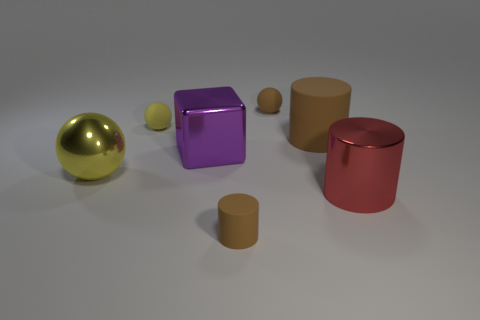Add 3 large purple blocks. How many objects exist? 10 Subtract all yellow metallic balls. How many balls are left? 2 Subtract all cubes. How many objects are left? 6 Add 6 small blue shiny cubes. How many small blue shiny cubes exist? 6 Subtract all brown cylinders. How many cylinders are left? 1 Subtract 1 yellow spheres. How many objects are left? 6 Subtract 1 blocks. How many blocks are left? 0 Subtract all brown cubes. Subtract all yellow spheres. How many cubes are left? 1 Subtract all gray balls. How many purple cylinders are left? 0 Subtract all tiny brown balls. Subtract all small things. How many objects are left? 3 